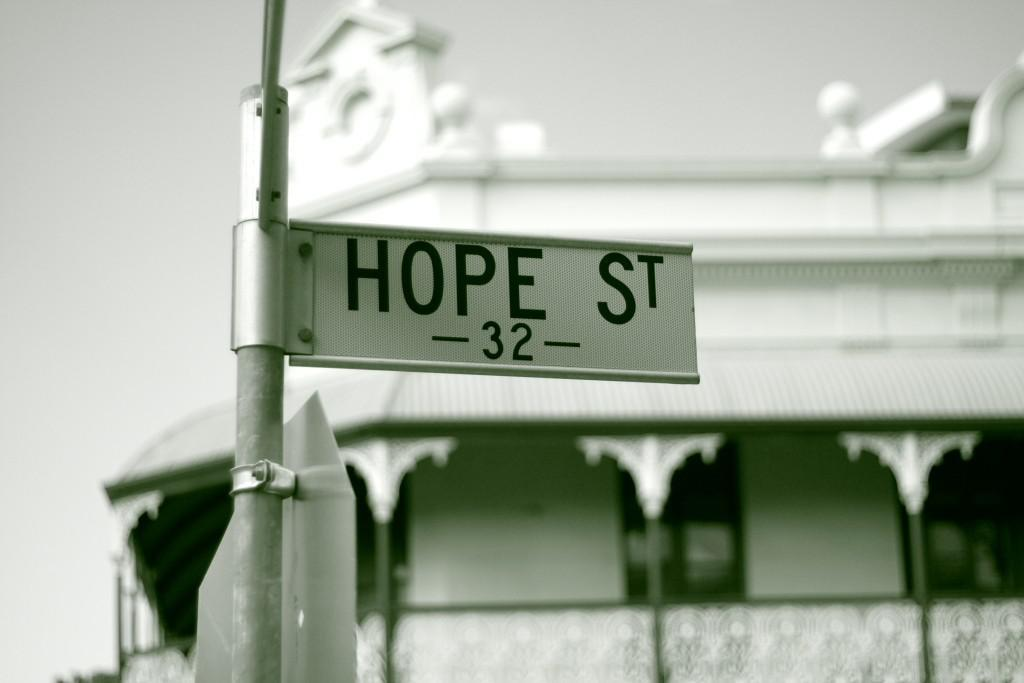What is the main object in the image with a sign board? There is a pole with a sign board in the image. What type of structure can be seen in the image? There is a building with pillars in the image. What part of the natural environment is visible in the image? The sky is visible in the image. How would you describe the background of the image? The background appears blurry. What type of pets are having a discussion in the alley in the image? There are no pets or alley present in the image; it features a pole with a sign board, a building with pillars, and a blurry background. 